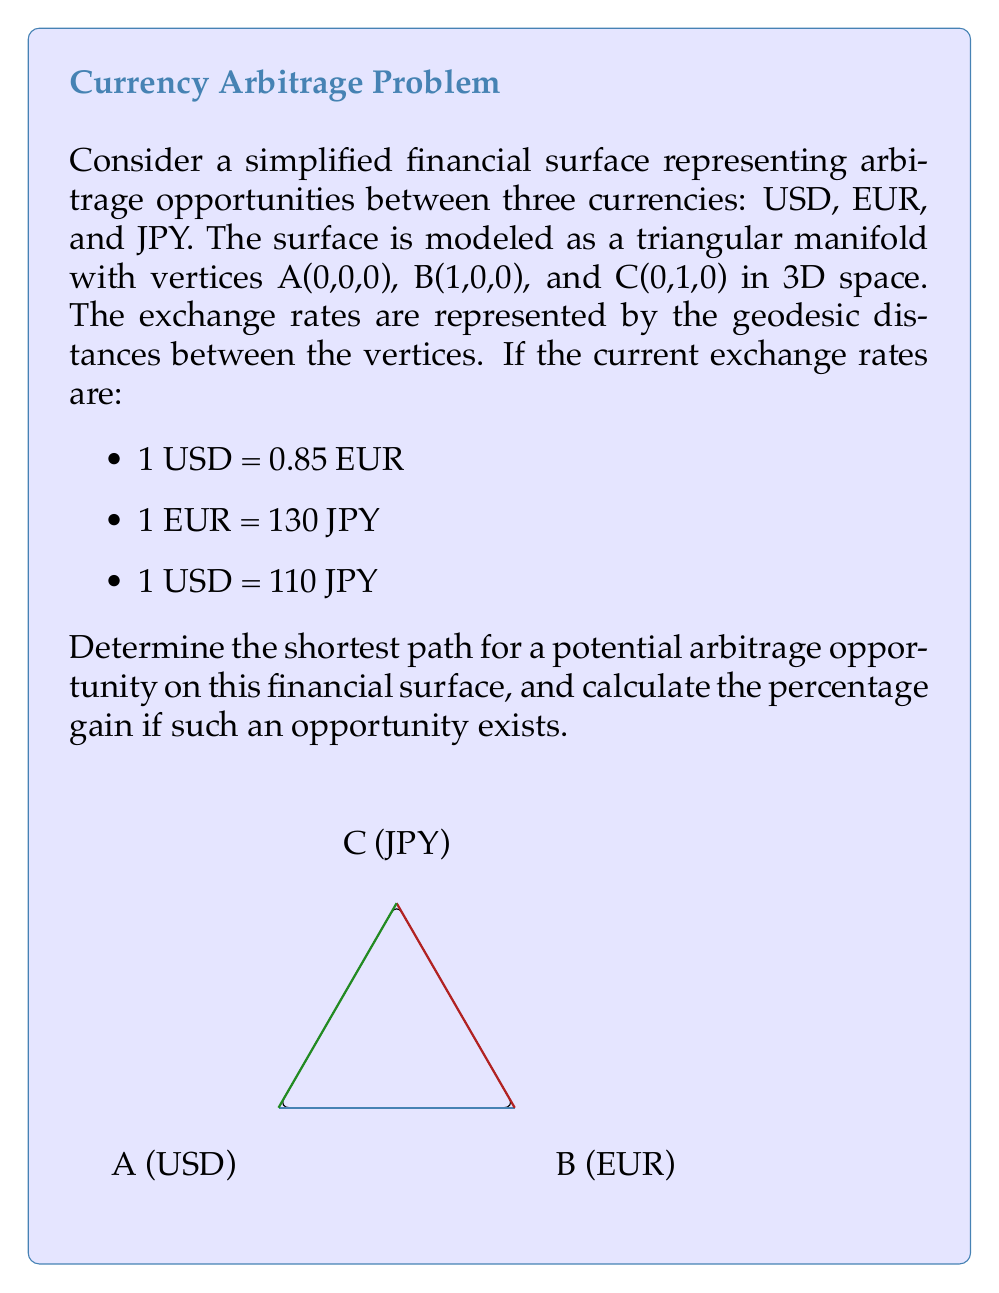Provide a solution to this math problem. To solve this problem, we'll follow these steps:

1) First, we need to convert the exchange rates to a common base. Let's use USD as the base:
   USD to EUR: 1 USD = 0.85 EUR
   USD to JPY: 1 USD = 110 JPY
   EUR to JPY: 1 EUR = 130 JPY, so 0.85 EUR = 110.5 JPY

2) Now, we can see a potential arbitrage opportunity:
   1 USD → 110 JPY (direct)
   1 USD → 0.85 EUR → 110.5 JPY (indirect)

3) To calculate the percentage gain:
   $$\text{Gain} = \frac{110.5 - 110}{110} \times 100\% = 0.4545\%$$

4) The shortest path for this arbitrage opportunity on the financial surface would be:
   USD (A) → EUR (B) → JPY (C) → USD (A)

5) In terms of the triangular manifold:
   - Start at vertex A (USD)
   - Move to vertex B (EUR)
   - Then to vertex C (JPY)
   - Finally, return to vertex A (USD)

This path forms a complete cycle on the triangular surface, exploiting the discrepancy in exchange rates to generate a profit.

6) The geodesic distances between the vertices represent the exchange rates. The arbitrage opportunity exists because the product of these distances around the cycle is not equal to 1, which would be the case in a perfectly efficient market.
Answer: Shortest path: USD → EUR → JPY → USD; Gain: 0.4545% 